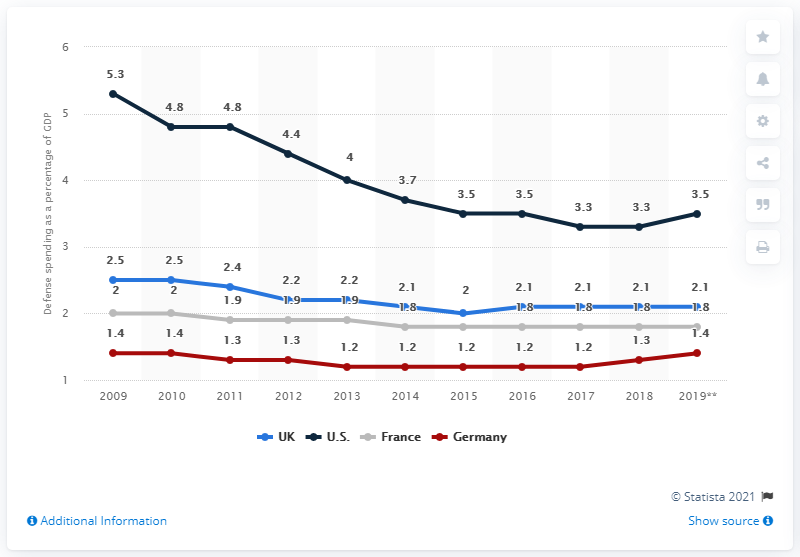Draw attention to some important aspects in this diagram. In 2012, the share of defense expenditure in the United Kingdom was 2.2%. In the last 8 years, the defense spending in Germany has been below 1.4% of its Gross Domestic Product (GDP). France's defense expenditure increased more than double in 2019 compared to the previous year. 